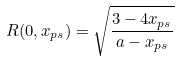Convert formula to latex. <formula><loc_0><loc_0><loc_500><loc_500>R ( 0 , x _ { p s } ) = \sqrt { \frac { 3 - 4 x _ { p s } } { a - x _ { p s } } }</formula> 